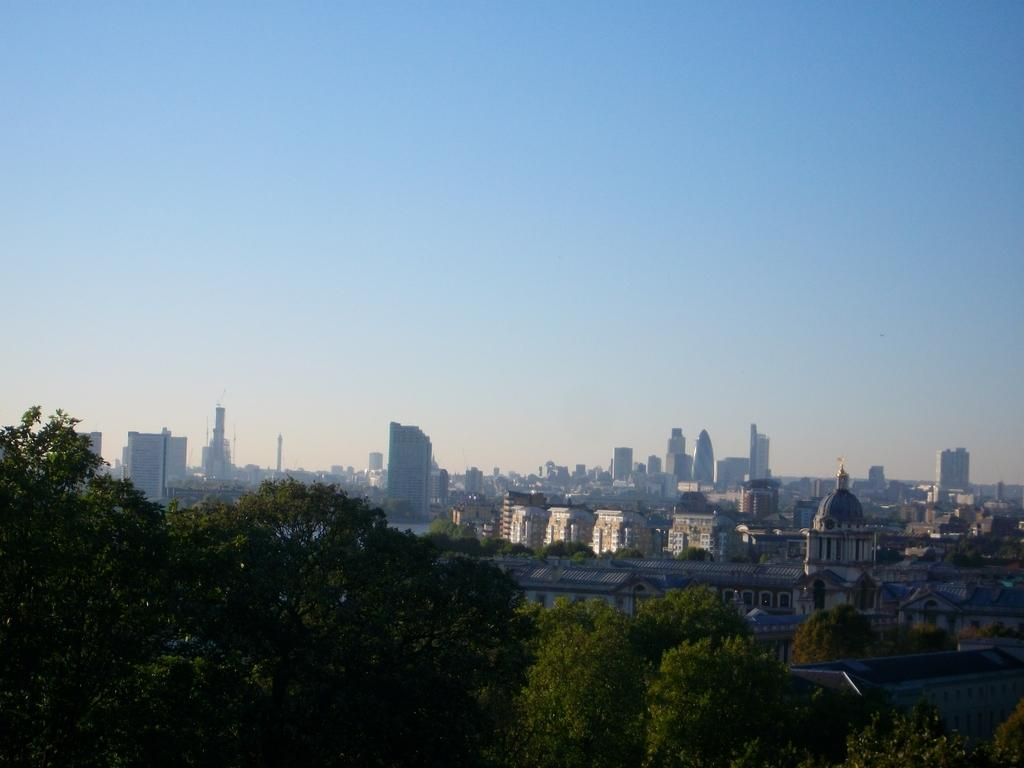What type of vegetation is at the bottom of the image? There are trees at the bottom of the image. What can be seen in the background of the image? Multiple buildings are visible in the background of the image. How are the buildings arranged in the image? The buildings are positioned one beside the other. What is visible at the top of the image? The sky is visible at the top of the image. Can you tell me how many robins are perched on the trees in the image? There are no robins present in the image; it features trees and buildings. What direction is the wind blowing in the image? There is no indication of wind in the image, as it only shows trees, buildings, and the sky. 